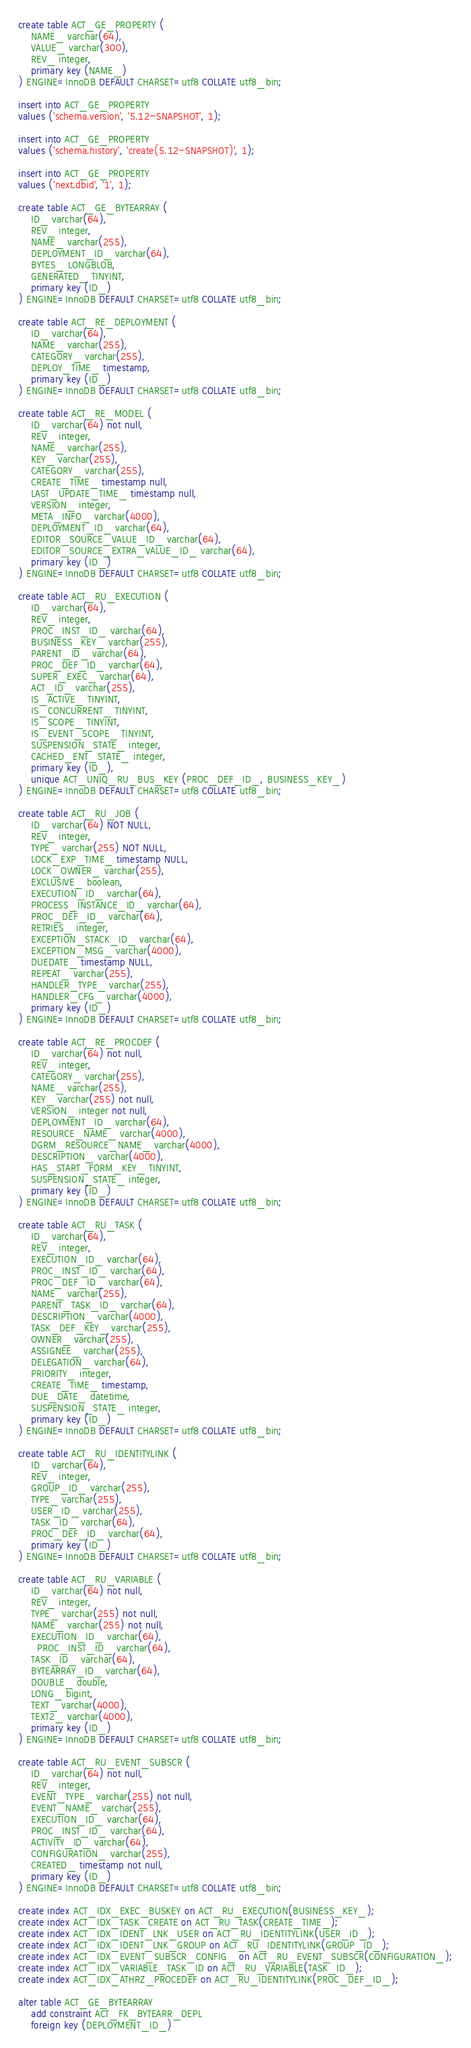Convert code to text. <code><loc_0><loc_0><loc_500><loc_500><_SQL_>create table ACT_GE_PROPERTY (
    NAME_ varchar(64),
    VALUE_ varchar(300),
    REV_ integer,
    primary key (NAME_)
) ENGINE=InnoDB DEFAULT CHARSET=utf8 COLLATE utf8_bin;

insert into ACT_GE_PROPERTY
values ('schema.version', '5.12-SNAPSHOT', 1);

insert into ACT_GE_PROPERTY
values ('schema.history', 'create(5.12-SNAPSHOT)', 1);

insert into ACT_GE_PROPERTY
values ('next.dbid', '1', 1);

create table ACT_GE_BYTEARRAY (
    ID_ varchar(64),
    REV_ integer,
    NAME_ varchar(255),
    DEPLOYMENT_ID_ varchar(64),
    BYTES_ LONGBLOB,
    GENERATED_ TINYINT,
    primary key (ID_)
) ENGINE=InnoDB DEFAULT CHARSET=utf8 COLLATE utf8_bin;

create table ACT_RE_DEPLOYMENT (
    ID_ varchar(64),
    NAME_ varchar(255),
    CATEGORY_ varchar(255),
    DEPLOY_TIME_ timestamp,
    primary key (ID_)
) ENGINE=InnoDB DEFAULT CHARSET=utf8 COLLATE utf8_bin;

create table ACT_RE_MODEL (
    ID_ varchar(64) not null,
    REV_ integer,
    NAME_ varchar(255),
    KEY_ varchar(255),
    CATEGORY_ varchar(255),
    CREATE_TIME_ timestamp null,
    LAST_UPDATE_TIME_ timestamp null,
    VERSION_ integer,
    META_INFO_ varchar(4000),
    DEPLOYMENT_ID_ varchar(64),
    EDITOR_SOURCE_VALUE_ID_ varchar(64),
    EDITOR_SOURCE_EXTRA_VALUE_ID_ varchar(64),
    primary key (ID_)
) ENGINE=InnoDB DEFAULT CHARSET=utf8 COLLATE utf8_bin;

create table ACT_RU_EXECUTION (
    ID_ varchar(64),
    REV_ integer,
    PROC_INST_ID_ varchar(64),
    BUSINESS_KEY_ varchar(255),
    PARENT_ID_ varchar(64),
    PROC_DEF_ID_ varchar(64),
    SUPER_EXEC_ varchar(64),
    ACT_ID_ varchar(255),
    IS_ACTIVE_ TINYINT,
    IS_CONCURRENT_ TINYINT,
    IS_SCOPE_ TINYINT,
    IS_EVENT_SCOPE_ TINYINT,
    SUSPENSION_STATE_ integer,
    CACHED_ENT_STATE_ integer,
    primary key (ID_),
    unique ACT_UNIQ_RU_BUS_KEY (PROC_DEF_ID_, BUSINESS_KEY_)
) ENGINE=InnoDB DEFAULT CHARSET=utf8 COLLATE utf8_bin;

create table ACT_RU_JOB (
    ID_ varchar(64) NOT NULL,
	REV_ integer,
    TYPE_ varchar(255) NOT NULL,
    LOCK_EXP_TIME_ timestamp NULL,
    LOCK_OWNER_ varchar(255),
    EXCLUSIVE_ boolean,
    EXECUTION_ID_ varchar(64),
    PROCESS_INSTANCE_ID_ varchar(64),
    PROC_DEF_ID_ varchar(64),
    RETRIES_ integer,
    EXCEPTION_STACK_ID_ varchar(64),
    EXCEPTION_MSG_ varchar(4000),
    DUEDATE_ timestamp NULL,
    REPEAT_ varchar(255),
    HANDLER_TYPE_ varchar(255),
    HANDLER_CFG_ varchar(4000),
    primary key (ID_)
) ENGINE=InnoDB DEFAULT CHARSET=utf8 COLLATE utf8_bin;

create table ACT_RE_PROCDEF (
    ID_ varchar(64) not null,
    REV_ integer,
    CATEGORY_ varchar(255),
    NAME_ varchar(255),
    KEY_ varchar(255) not null,
    VERSION_ integer not null,
    DEPLOYMENT_ID_ varchar(64),
    RESOURCE_NAME_ varchar(4000),
    DGRM_RESOURCE_NAME_ varchar(4000),
    DESCRIPTION_ varchar(4000),
    HAS_START_FORM_KEY_ TINYINT,
    SUSPENSION_STATE_ integer,
    primary key (ID_)
) ENGINE=InnoDB DEFAULT CHARSET=utf8 COLLATE utf8_bin;

create table ACT_RU_TASK (
    ID_ varchar(64),
    REV_ integer,
    EXECUTION_ID_ varchar(64),
    PROC_INST_ID_ varchar(64),
    PROC_DEF_ID_ varchar(64),
    NAME_ varchar(255),
    PARENT_TASK_ID_ varchar(64),
    DESCRIPTION_ varchar(4000),
    TASK_DEF_KEY_ varchar(255),
    OWNER_ varchar(255),
    ASSIGNEE_ varchar(255),
    DELEGATION_ varchar(64),
    PRIORITY_ integer,
    CREATE_TIME_ timestamp,
    DUE_DATE_ datetime,
    SUSPENSION_STATE_ integer,
    primary key (ID_)
) ENGINE=InnoDB DEFAULT CHARSET=utf8 COLLATE utf8_bin;

create table ACT_RU_IDENTITYLINK (
    ID_ varchar(64),
    REV_ integer,
    GROUP_ID_ varchar(255),
    TYPE_ varchar(255),
    USER_ID_ varchar(255),
    TASK_ID_ varchar(64),
    PROC_DEF_ID_ varchar(64),    
    primary key (ID_)
) ENGINE=InnoDB DEFAULT CHARSET=utf8 COLLATE utf8_bin;

create table ACT_RU_VARIABLE (
    ID_ varchar(64) not null,
    REV_ integer,
    TYPE_ varchar(255) not null,
    NAME_ varchar(255) not null,
    EXECUTION_ID_ varchar(64),
	  PROC_INST_ID_ varchar(64),
    TASK_ID_ varchar(64),
    BYTEARRAY_ID_ varchar(64),
    DOUBLE_ double,
    LONG_ bigint,
    TEXT_ varchar(4000),
    TEXT2_ varchar(4000),
    primary key (ID_)
) ENGINE=InnoDB DEFAULT CHARSET=utf8 COLLATE utf8_bin;

create table ACT_RU_EVENT_SUBSCR (
    ID_ varchar(64) not null,
    REV_ integer,
    EVENT_TYPE_ varchar(255) not null,
    EVENT_NAME_ varchar(255),
    EXECUTION_ID_ varchar(64),
    PROC_INST_ID_ varchar(64),
    ACTIVITY_ID_ varchar(64),
    CONFIGURATION_ varchar(255),
    CREATED_ timestamp not null,
    primary key (ID_)
) ENGINE=InnoDB DEFAULT CHARSET=utf8 COLLATE utf8_bin;

create index ACT_IDX_EXEC_BUSKEY on ACT_RU_EXECUTION(BUSINESS_KEY_);
create index ACT_IDX_TASK_CREATE on ACT_RU_TASK(CREATE_TIME_);
create index ACT_IDX_IDENT_LNK_USER on ACT_RU_IDENTITYLINK(USER_ID_);
create index ACT_IDX_IDENT_LNK_GROUP on ACT_RU_IDENTITYLINK(GROUP_ID_);
create index ACT_IDX_EVENT_SUBSCR_CONFIG_ on ACT_RU_EVENT_SUBSCR(CONFIGURATION_);
create index ACT_IDX_VARIABLE_TASK_ID on ACT_RU_VARIABLE(TASK_ID_);
create index ACT_IDX_ATHRZ_PROCEDEF on ACT_RU_IDENTITYLINK(PROC_DEF_ID_);

alter table ACT_GE_BYTEARRAY
    add constraint ACT_FK_BYTEARR_DEPL 
    foreign key (DEPLOYMENT_ID_) </code> 